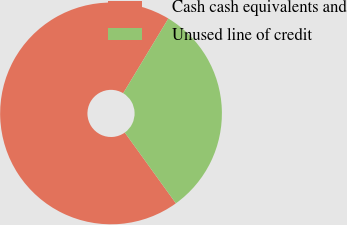<chart> <loc_0><loc_0><loc_500><loc_500><pie_chart><fcel>Cash cash equivalents and<fcel>Unused line of credit<nl><fcel>68.6%<fcel>31.4%<nl></chart> 